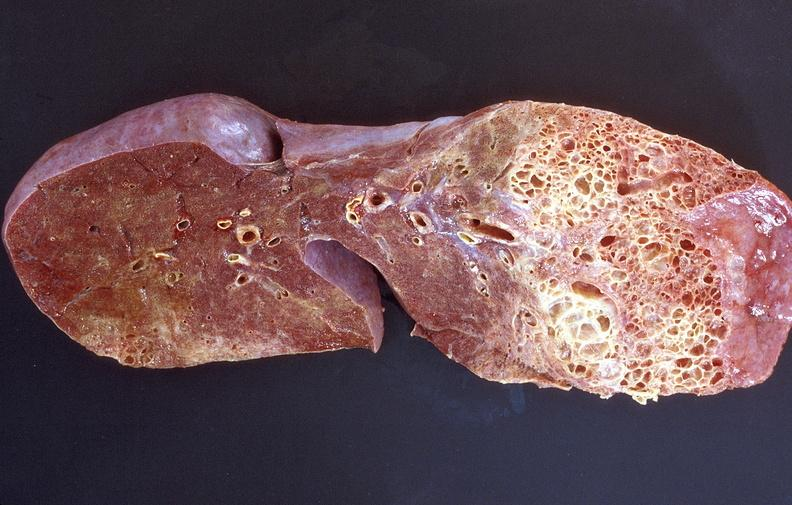what is present?
Answer the question using a single word or phrase. Respiratory 